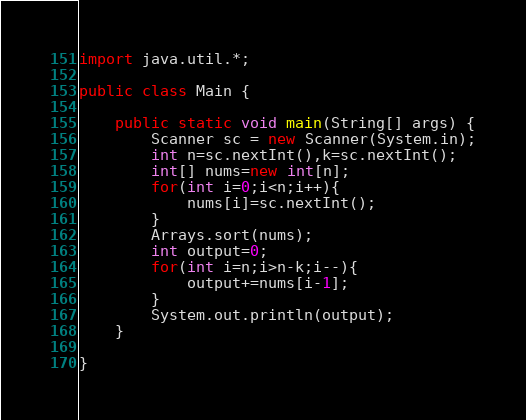<code> <loc_0><loc_0><loc_500><loc_500><_Java_>import java.util.*;

public class Main {

    public static void main(String[] args) {
        Scanner sc = new Scanner(System.in);
        int n=sc.nextInt(),k=sc.nextInt();
        int[] nums=new int[n];
        for(int i=0;i<n;i++){
            nums[i]=sc.nextInt();
        }
        Arrays.sort(nums);
        int output=0;
        for(int i=n;i>n-k;i--){
            output+=nums[i-1];
        }
        System.out.println(output);
    }

}</code> 